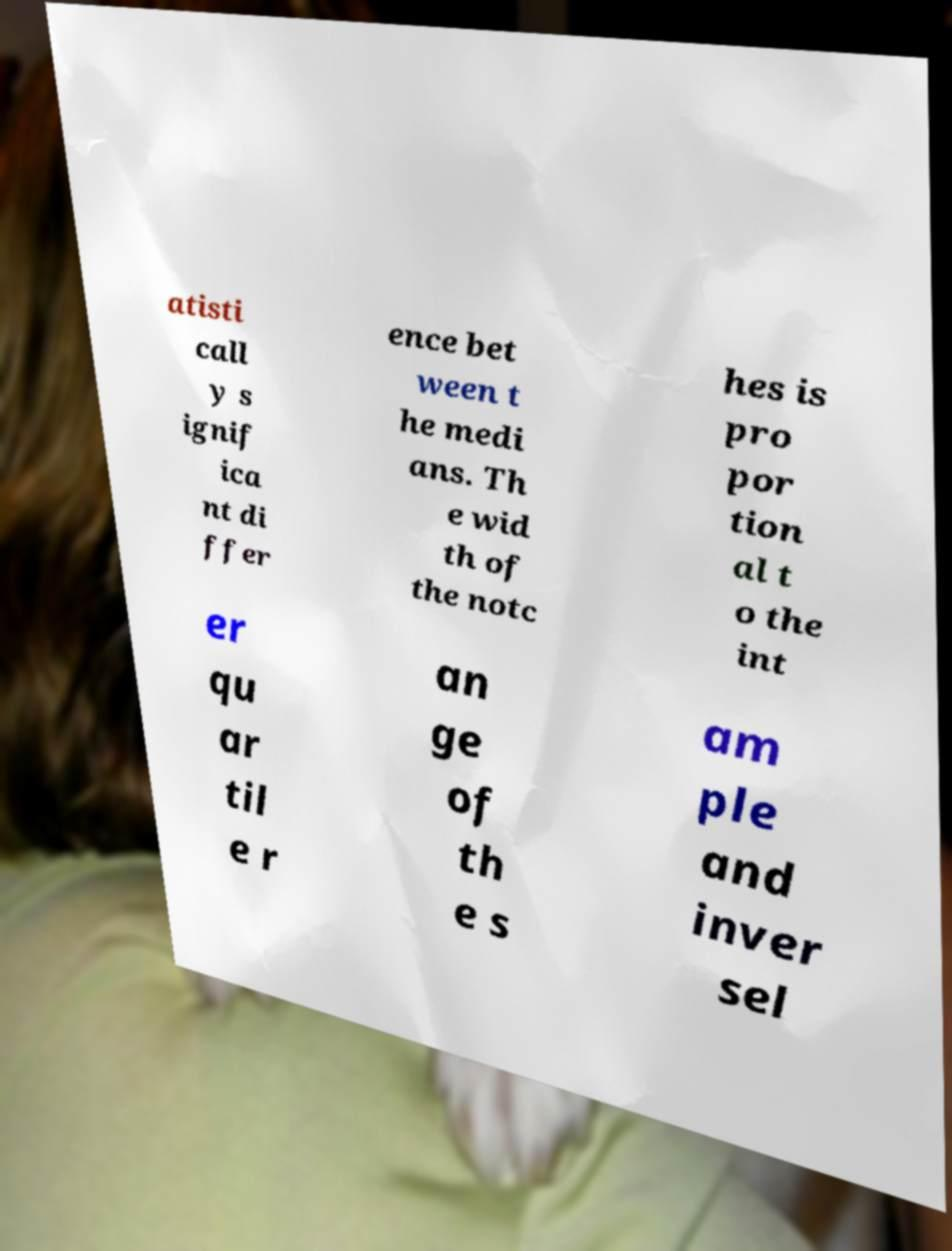I need the written content from this picture converted into text. Can you do that? atisti call y s ignif ica nt di ffer ence bet ween t he medi ans. Th e wid th of the notc hes is pro por tion al t o the int er qu ar til e r an ge of th e s am ple and inver sel 